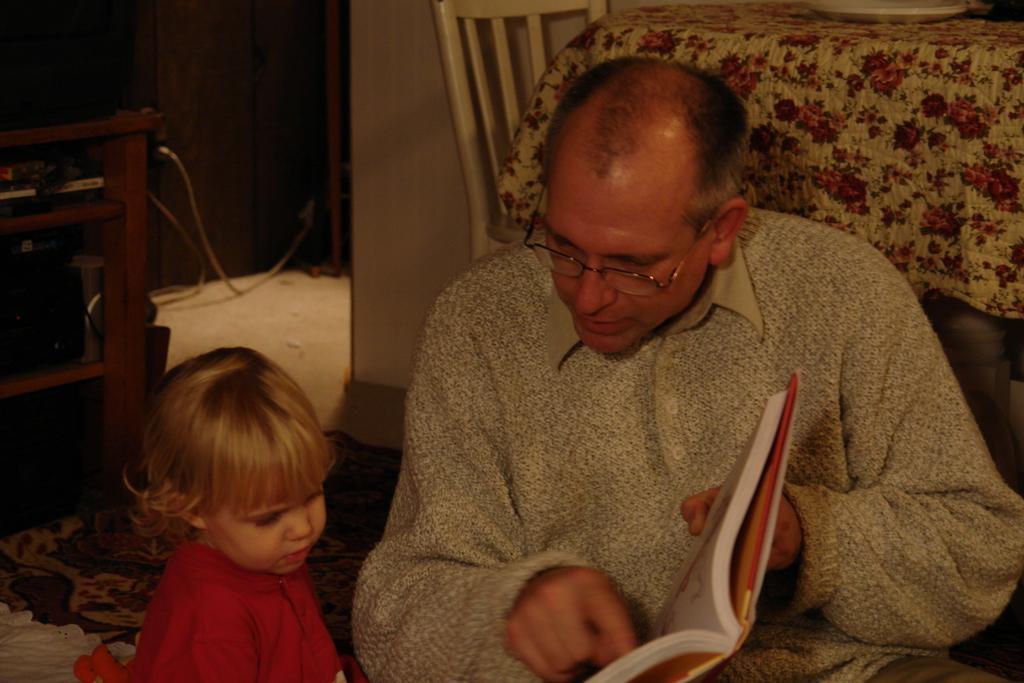How would you summarize this image in a sentence or two? In this picture we can see a man and a kid sitting, this man is holding a book, on the left side there is a table, on the right side we can see a chair and a cloth, at the bottom there is mat. 